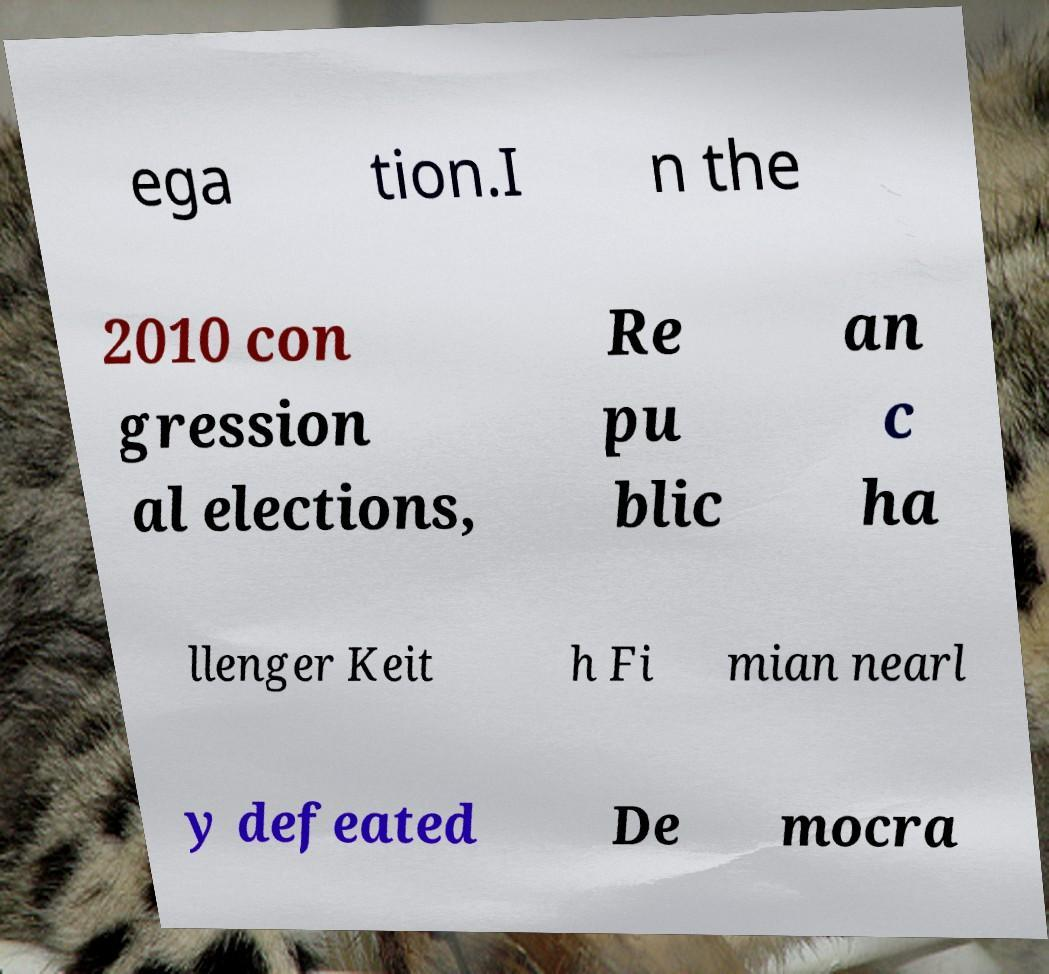For documentation purposes, I need the text within this image transcribed. Could you provide that? ega tion.I n the 2010 con gression al elections, Re pu blic an c ha llenger Keit h Fi mian nearl y defeated De mocra 